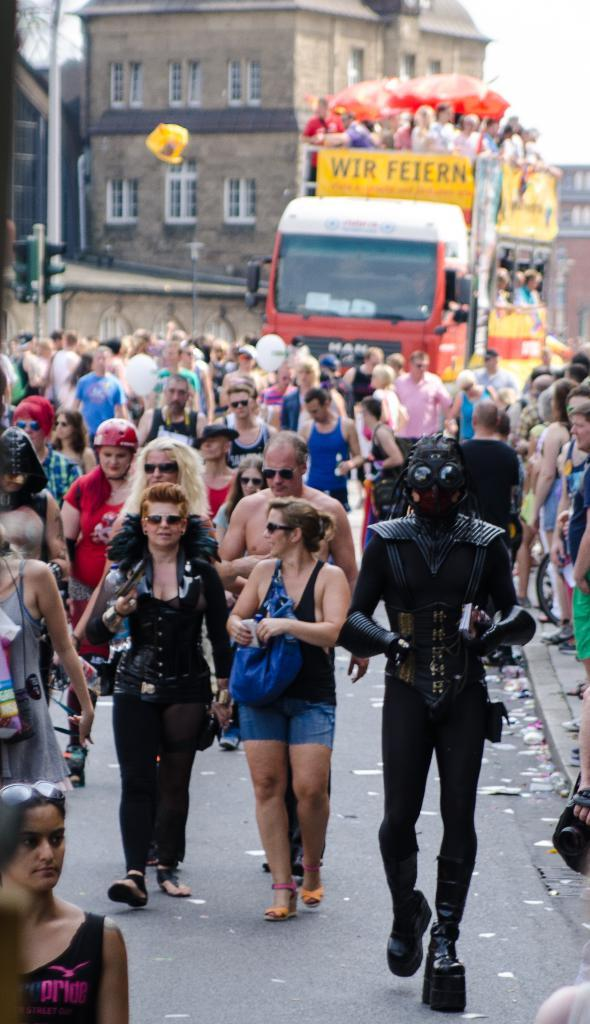How many people are in the image? There is a group of people in the image, but the exact number cannot be determined from the provided facts. What type of vehicle is in the image? There is a vehicle in the image, but the specific type cannot be determined from the provided facts. What is the pole in the image used for? The pole in the image is likely used to support the traffic signal, but its exact purpose cannot be determined from the provided facts. What is the condition of the sky in the image? The sky is visible in the background of the image, but its condition (e.g., clear, cloudy) cannot be determined from the provided facts. What can be seen in the background of the image? There are buildings and the sky visible in the background of the image. Where is the rat hiding on the stage in the image? There is no rat or stage present in the image. What type of bone is being used as a prop in the image? There is no bone present in the image. 